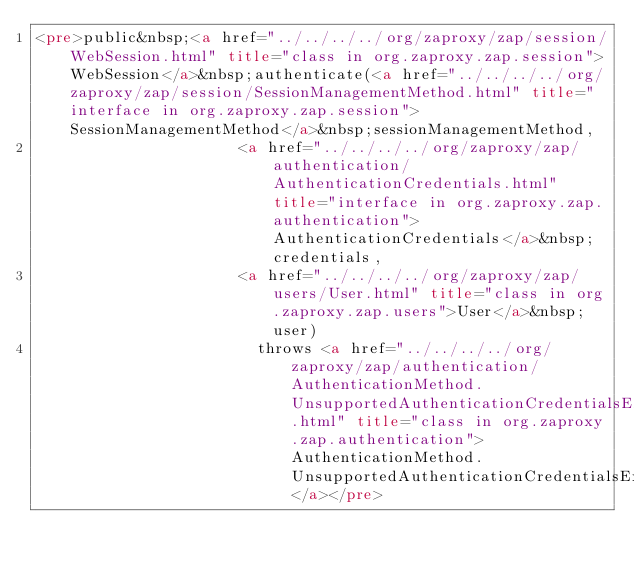<code> <loc_0><loc_0><loc_500><loc_500><_HTML_><pre>public&nbsp;<a href="../../../../org/zaproxy/zap/session/WebSession.html" title="class in org.zaproxy.zap.session">WebSession</a>&nbsp;authenticate(<a href="../../../../org/zaproxy/zap/session/SessionManagementMethod.html" title="interface in org.zaproxy.zap.session">SessionManagementMethod</a>&nbsp;sessionManagementMethod,
                      <a href="../../../../org/zaproxy/zap/authentication/AuthenticationCredentials.html" title="interface in org.zaproxy.zap.authentication">AuthenticationCredentials</a>&nbsp;credentials,
                      <a href="../../../../org/zaproxy/zap/users/User.html" title="class in org.zaproxy.zap.users">User</a>&nbsp;user)
                        throws <a href="../../../../org/zaproxy/zap/authentication/AuthenticationMethod.UnsupportedAuthenticationCredentialsException.html" title="class in org.zaproxy.zap.authentication">AuthenticationMethod.UnsupportedAuthenticationCredentialsException</a></pre></code> 